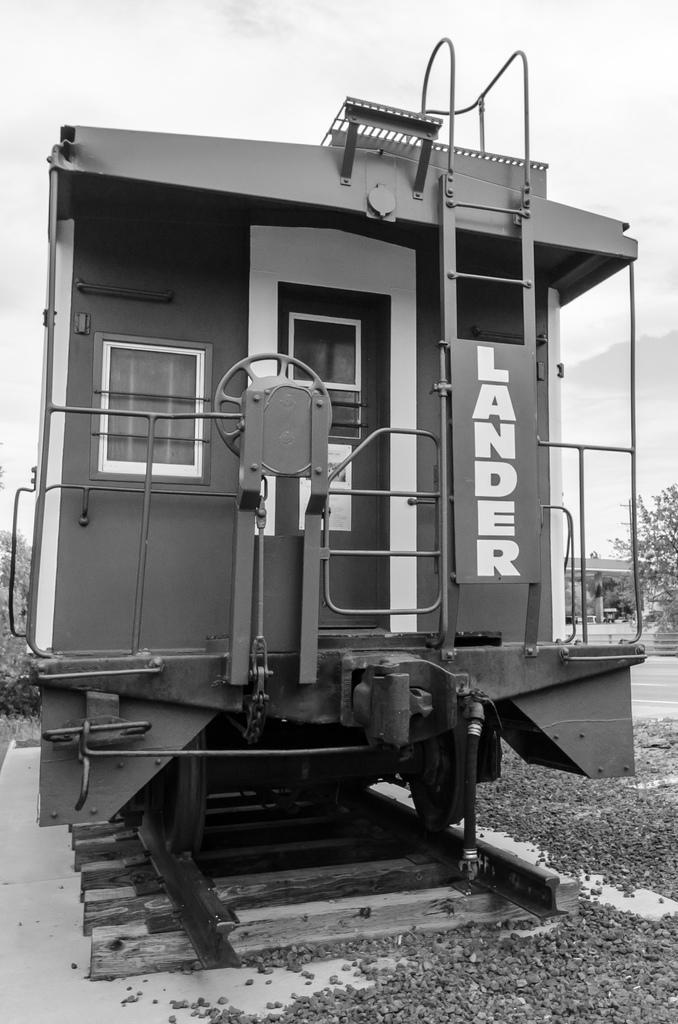How would you summarize this image in a sentence or two? In this I can see a train on the railway track and I can see text on it and I can see few trees and a cloudy sky and few small stones on the ground. 